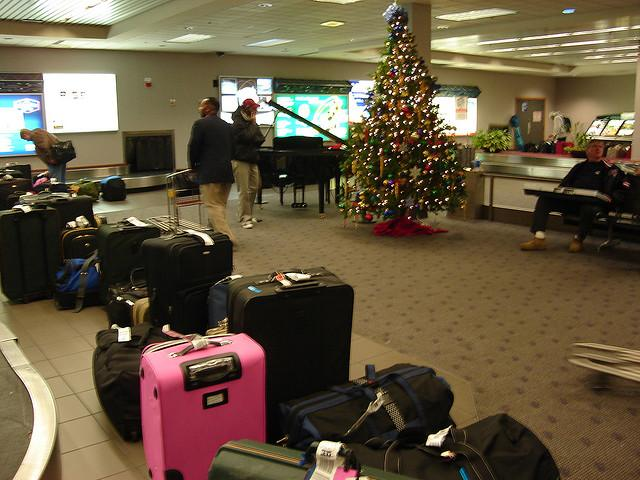A baggage carousel is a device generally at where?

Choices:
A) school
B) hospital
C) malls
D) airport airport 